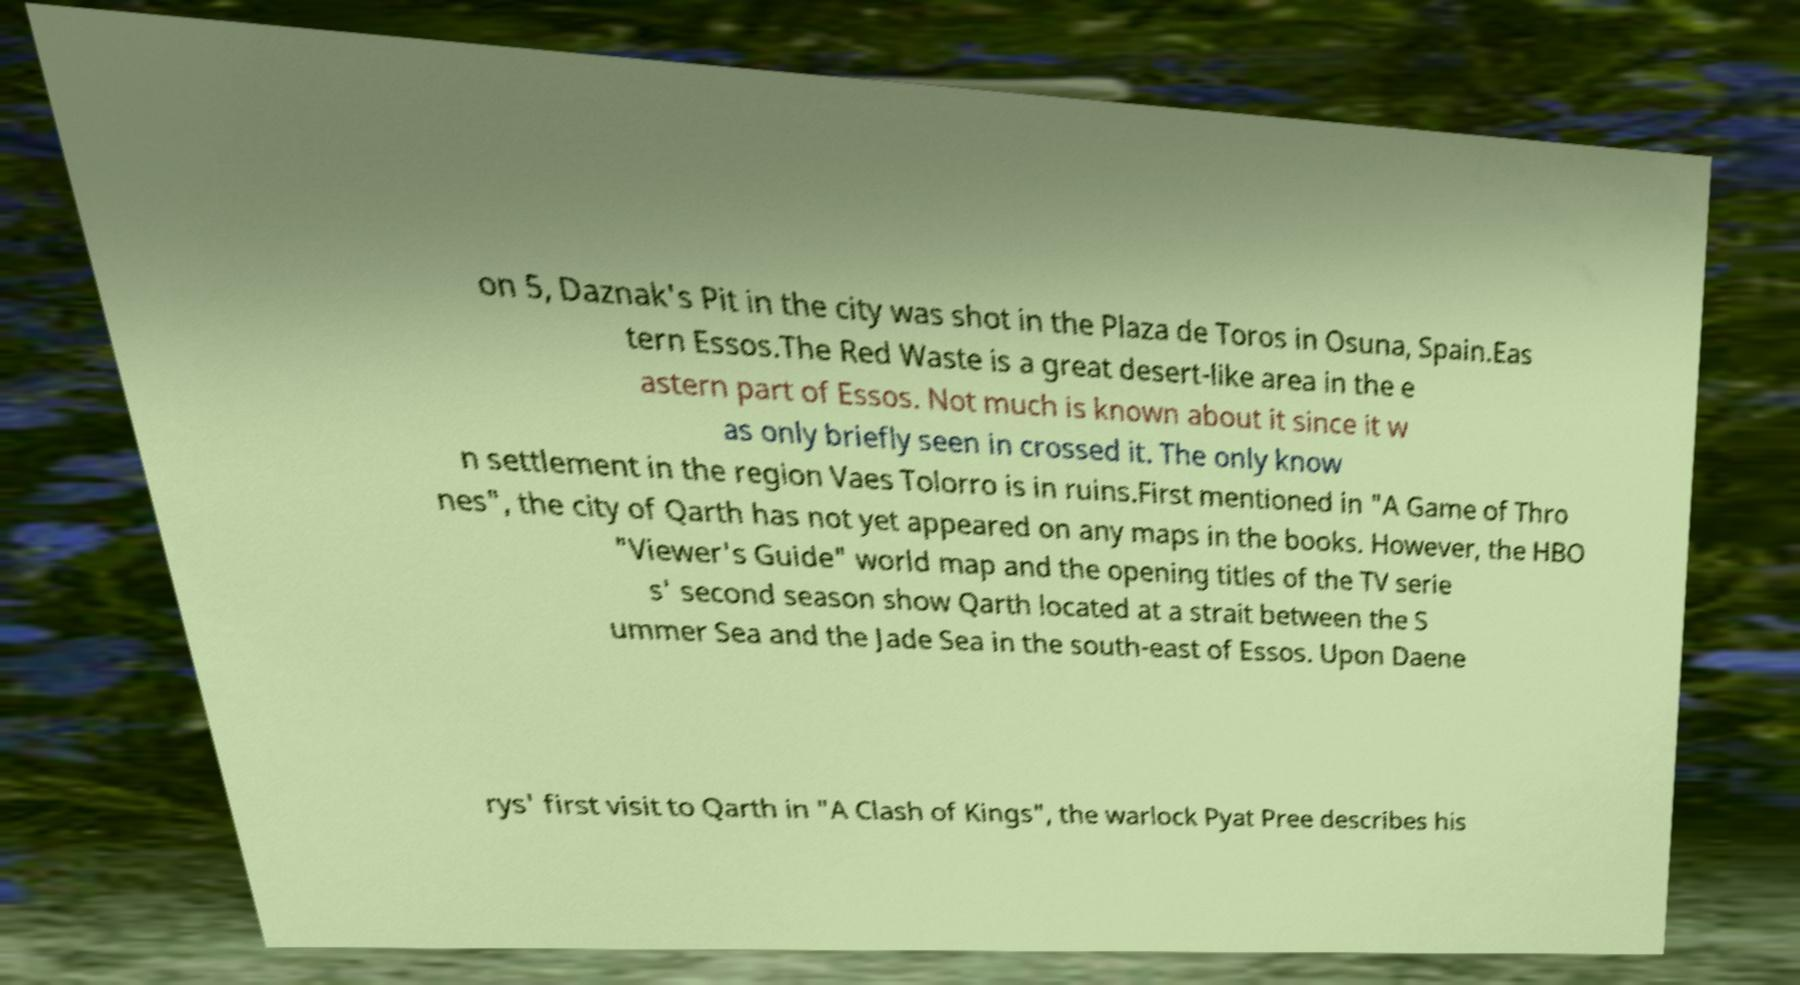There's text embedded in this image that I need extracted. Can you transcribe it verbatim? on 5, Daznak's Pit in the city was shot in the Plaza de Toros in Osuna, Spain.Eas tern Essos.The Red Waste is a great desert-like area in the e astern part of Essos. Not much is known about it since it w as only briefly seen in crossed it. The only know n settlement in the region Vaes Tolorro is in ruins.First mentioned in "A Game of Thro nes", the city of Qarth has not yet appeared on any maps in the books. However, the HBO "Viewer's Guide" world map and the opening titles of the TV serie s' second season show Qarth located at a strait between the S ummer Sea and the Jade Sea in the south-east of Essos. Upon Daene rys' first visit to Qarth in "A Clash of Kings", the warlock Pyat Pree describes his 